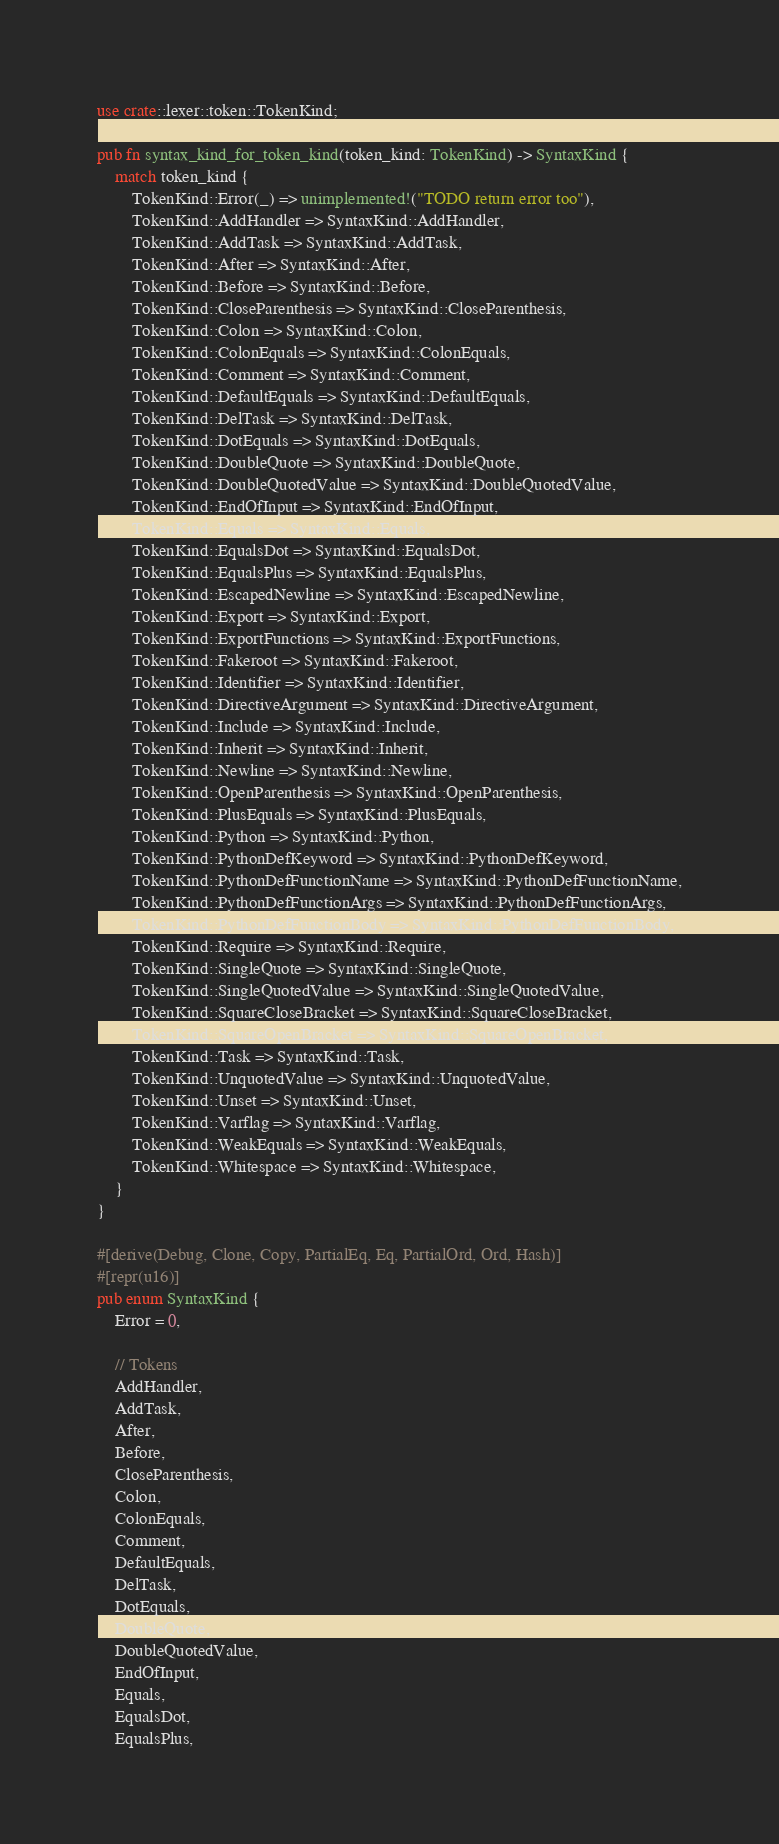Convert code to text. <code><loc_0><loc_0><loc_500><loc_500><_Rust_>use crate::lexer::token::TokenKind;

pub fn syntax_kind_for_token_kind(token_kind: TokenKind) -> SyntaxKind {
    match token_kind {
        TokenKind::Error(_) => unimplemented!("TODO return error too"),
        TokenKind::AddHandler => SyntaxKind::AddHandler,
        TokenKind::AddTask => SyntaxKind::AddTask,
        TokenKind::After => SyntaxKind::After,
        TokenKind::Before => SyntaxKind::Before,
        TokenKind::CloseParenthesis => SyntaxKind::CloseParenthesis,
        TokenKind::Colon => SyntaxKind::Colon,
        TokenKind::ColonEquals => SyntaxKind::ColonEquals,
        TokenKind::Comment => SyntaxKind::Comment,
        TokenKind::DefaultEquals => SyntaxKind::DefaultEquals,
        TokenKind::DelTask => SyntaxKind::DelTask,
        TokenKind::DotEquals => SyntaxKind::DotEquals,
        TokenKind::DoubleQuote => SyntaxKind::DoubleQuote,
        TokenKind::DoubleQuotedValue => SyntaxKind::DoubleQuotedValue,
        TokenKind::EndOfInput => SyntaxKind::EndOfInput,
        TokenKind::Equals => SyntaxKind::Equals,
        TokenKind::EqualsDot => SyntaxKind::EqualsDot,
        TokenKind::EqualsPlus => SyntaxKind::EqualsPlus,
        TokenKind::EscapedNewline => SyntaxKind::EscapedNewline,
        TokenKind::Export => SyntaxKind::Export,
        TokenKind::ExportFunctions => SyntaxKind::ExportFunctions,
        TokenKind::Fakeroot => SyntaxKind::Fakeroot,
        TokenKind::Identifier => SyntaxKind::Identifier,
        TokenKind::DirectiveArgument => SyntaxKind::DirectiveArgument,
        TokenKind::Include => SyntaxKind::Include,
        TokenKind::Inherit => SyntaxKind::Inherit,
        TokenKind::Newline => SyntaxKind::Newline,
        TokenKind::OpenParenthesis => SyntaxKind::OpenParenthesis,
        TokenKind::PlusEquals => SyntaxKind::PlusEquals,
        TokenKind::Python => SyntaxKind::Python,
        TokenKind::PythonDefKeyword => SyntaxKind::PythonDefKeyword,
        TokenKind::PythonDefFunctionName => SyntaxKind::PythonDefFunctionName,
        TokenKind::PythonDefFunctionArgs => SyntaxKind::PythonDefFunctionArgs,
        TokenKind::PythonDefFunctionBody => SyntaxKind::PythonDefFunctionBody,
        TokenKind::Require => SyntaxKind::Require,
        TokenKind::SingleQuote => SyntaxKind::SingleQuote,
        TokenKind::SingleQuotedValue => SyntaxKind::SingleQuotedValue,
        TokenKind::SquareCloseBracket => SyntaxKind::SquareCloseBracket,
        TokenKind::SquareOpenBracket => SyntaxKind::SquareOpenBracket,
        TokenKind::Task => SyntaxKind::Task,
        TokenKind::UnquotedValue => SyntaxKind::UnquotedValue,
        TokenKind::Unset => SyntaxKind::Unset,
        TokenKind::Varflag => SyntaxKind::Varflag,
        TokenKind::WeakEquals => SyntaxKind::WeakEquals,
        TokenKind::Whitespace => SyntaxKind::Whitespace,
    }
}

#[derive(Debug, Clone, Copy, PartialEq, Eq, PartialOrd, Ord, Hash)]
#[repr(u16)]
pub enum SyntaxKind {
    Error = 0,

    // Tokens
    AddHandler,
    AddTask,
    After,
    Before,
    CloseParenthesis,
    Colon,
    ColonEquals,
    Comment,
    DefaultEquals,
    DelTask,
    DotEquals,
    DoubleQuote,
    DoubleQuotedValue,
    EndOfInput,
    Equals,
    EqualsDot,
    EqualsPlus,</code> 